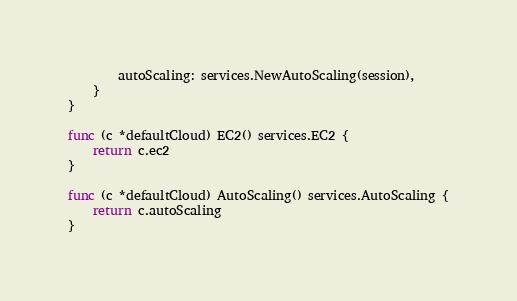<code> <loc_0><loc_0><loc_500><loc_500><_Go_>		autoScaling: services.NewAutoScaling(session),
	}
}

func (c *defaultCloud) EC2() services.EC2 {
	return c.ec2
}

func (c *defaultCloud) AutoScaling() services.AutoScaling {
	return c.autoScaling
}
</code> 